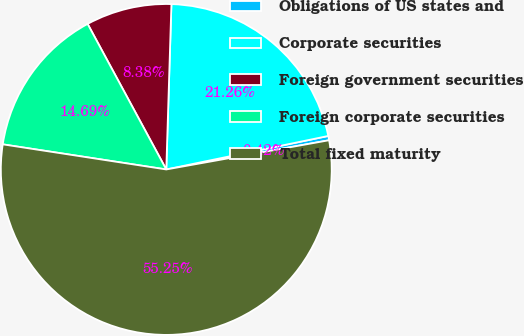Convert chart. <chart><loc_0><loc_0><loc_500><loc_500><pie_chart><fcel>Obligations of US states and<fcel>Corporate securities<fcel>Foreign government securities<fcel>Foreign corporate securities<fcel>Total fixed maturity<nl><fcel>0.42%<fcel>21.26%<fcel>8.38%<fcel>14.69%<fcel>55.25%<nl></chart> 